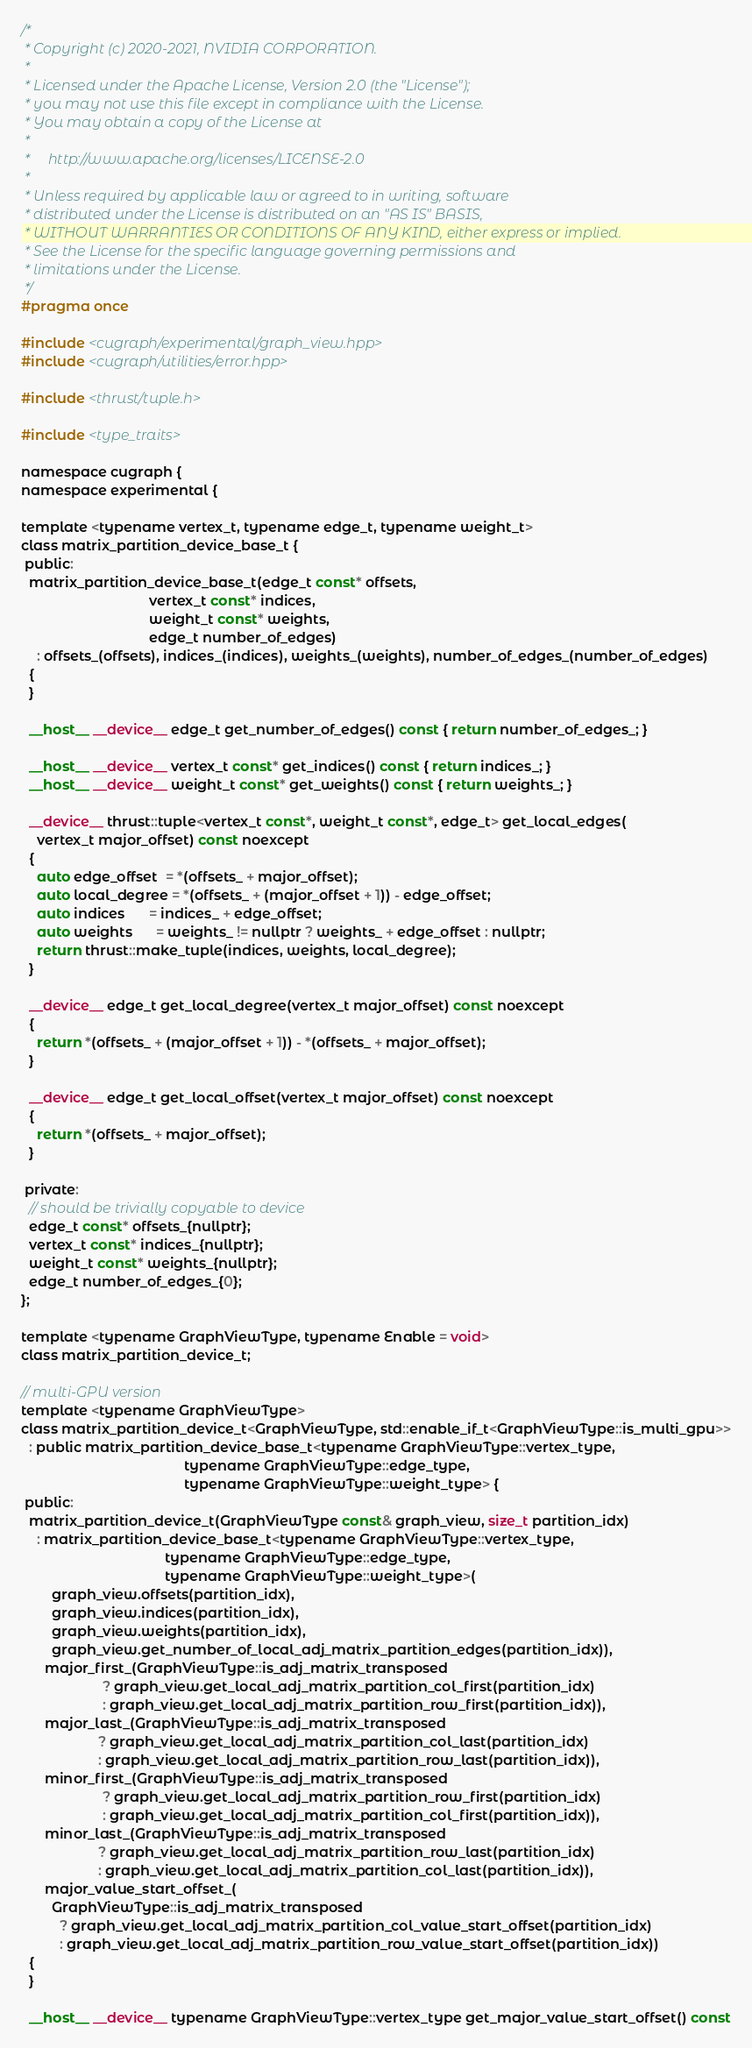Convert code to text. <code><loc_0><loc_0><loc_500><loc_500><_Cuda_>/*
 * Copyright (c) 2020-2021, NVIDIA CORPORATION.
 *
 * Licensed under the Apache License, Version 2.0 (the "License");
 * you may not use this file except in compliance with the License.
 * You may obtain a copy of the License at
 *
 *     http://www.apache.org/licenses/LICENSE-2.0
 *
 * Unless required by applicable law or agreed to in writing, software
 * distributed under the License is distributed on an "AS IS" BASIS,
 * WITHOUT WARRANTIES OR CONDITIONS OF ANY KIND, either express or implied.
 * See the License for the specific language governing permissions and
 * limitations under the License.
 */
#pragma once

#include <cugraph/experimental/graph_view.hpp>
#include <cugraph/utilities/error.hpp>

#include <thrust/tuple.h>

#include <type_traits>

namespace cugraph {
namespace experimental {

template <typename vertex_t, typename edge_t, typename weight_t>
class matrix_partition_device_base_t {
 public:
  matrix_partition_device_base_t(edge_t const* offsets,
                                 vertex_t const* indices,
                                 weight_t const* weights,
                                 edge_t number_of_edges)
    : offsets_(offsets), indices_(indices), weights_(weights), number_of_edges_(number_of_edges)
  {
  }

  __host__ __device__ edge_t get_number_of_edges() const { return number_of_edges_; }

  __host__ __device__ vertex_t const* get_indices() const { return indices_; }
  __host__ __device__ weight_t const* get_weights() const { return weights_; }

  __device__ thrust::tuple<vertex_t const*, weight_t const*, edge_t> get_local_edges(
    vertex_t major_offset) const noexcept
  {
    auto edge_offset  = *(offsets_ + major_offset);
    auto local_degree = *(offsets_ + (major_offset + 1)) - edge_offset;
    auto indices      = indices_ + edge_offset;
    auto weights      = weights_ != nullptr ? weights_ + edge_offset : nullptr;
    return thrust::make_tuple(indices, weights, local_degree);
  }

  __device__ edge_t get_local_degree(vertex_t major_offset) const noexcept
  {
    return *(offsets_ + (major_offset + 1)) - *(offsets_ + major_offset);
  }

  __device__ edge_t get_local_offset(vertex_t major_offset) const noexcept
  {
    return *(offsets_ + major_offset);
  }

 private:
  // should be trivially copyable to device
  edge_t const* offsets_{nullptr};
  vertex_t const* indices_{nullptr};
  weight_t const* weights_{nullptr};
  edge_t number_of_edges_{0};
};

template <typename GraphViewType, typename Enable = void>
class matrix_partition_device_t;

// multi-GPU version
template <typename GraphViewType>
class matrix_partition_device_t<GraphViewType, std::enable_if_t<GraphViewType::is_multi_gpu>>
  : public matrix_partition_device_base_t<typename GraphViewType::vertex_type,
                                          typename GraphViewType::edge_type,
                                          typename GraphViewType::weight_type> {
 public:
  matrix_partition_device_t(GraphViewType const& graph_view, size_t partition_idx)
    : matrix_partition_device_base_t<typename GraphViewType::vertex_type,
                                     typename GraphViewType::edge_type,
                                     typename GraphViewType::weight_type>(
        graph_view.offsets(partition_idx),
        graph_view.indices(partition_idx),
        graph_view.weights(partition_idx),
        graph_view.get_number_of_local_adj_matrix_partition_edges(partition_idx)),
      major_first_(GraphViewType::is_adj_matrix_transposed
                     ? graph_view.get_local_adj_matrix_partition_col_first(partition_idx)
                     : graph_view.get_local_adj_matrix_partition_row_first(partition_idx)),
      major_last_(GraphViewType::is_adj_matrix_transposed
                    ? graph_view.get_local_adj_matrix_partition_col_last(partition_idx)
                    : graph_view.get_local_adj_matrix_partition_row_last(partition_idx)),
      minor_first_(GraphViewType::is_adj_matrix_transposed
                     ? graph_view.get_local_adj_matrix_partition_row_first(partition_idx)
                     : graph_view.get_local_adj_matrix_partition_col_first(partition_idx)),
      minor_last_(GraphViewType::is_adj_matrix_transposed
                    ? graph_view.get_local_adj_matrix_partition_row_last(partition_idx)
                    : graph_view.get_local_adj_matrix_partition_col_last(partition_idx)),
      major_value_start_offset_(
        GraphViewType::is_adj_matrix_transposed
          ? graph_view.get_local_adj_matrix_partition_col_value_start_offset(partition_idx)
          : graph_view.get_local_adj_matrix_partition_row_value_start_offset(partition_idx))
  {
  }

  __host__ __device__ typename GraphViewType::vertex_type get_major_value_start_offset() const</code> 